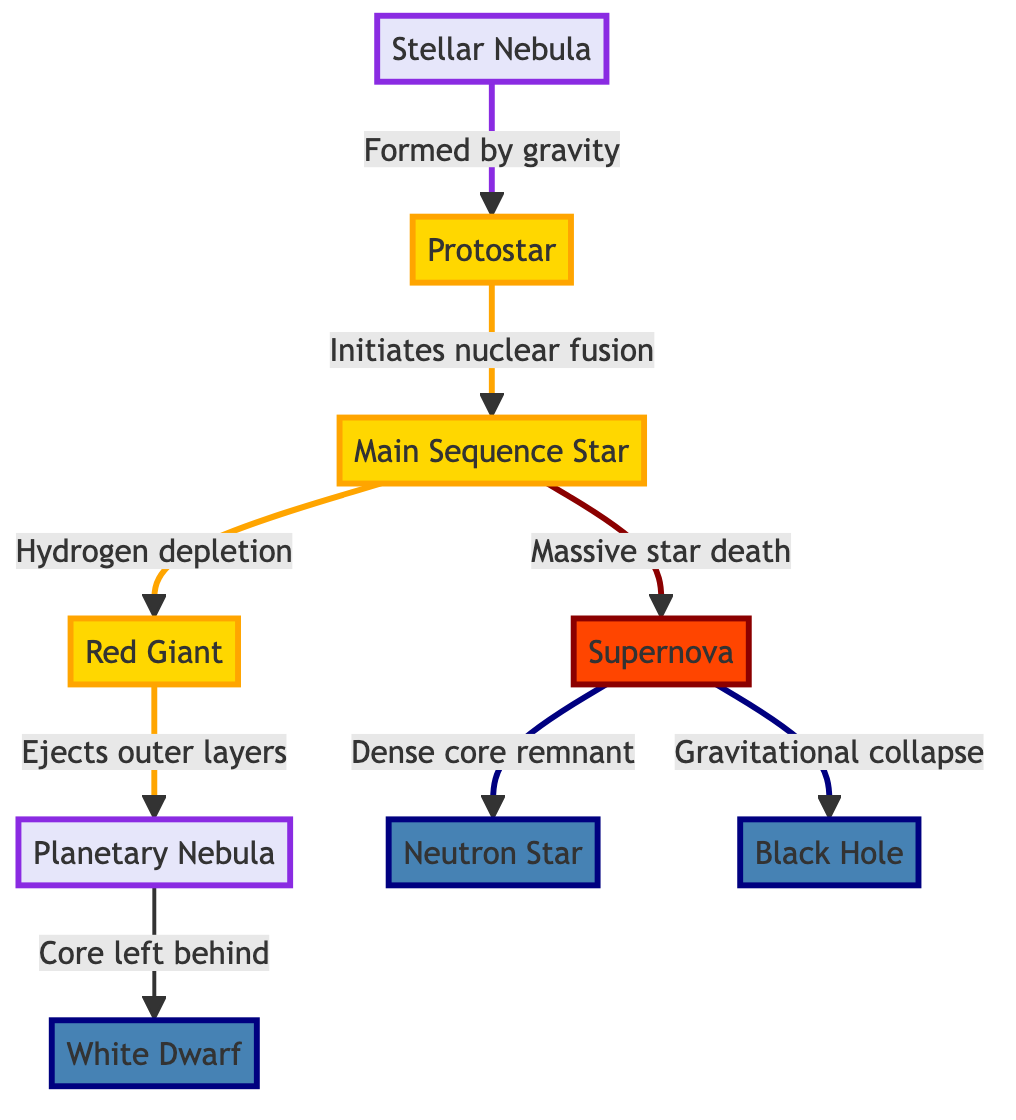What is the first stage of a star's lifecycle? The diagram indicates that the first stage of a star's lifecycle is represented by the node labeled "Stellar Nebula." This is also the starting point of the flow leading to the formation of a star.
Answer: Stellar Nebula How many main stages are shown in the lifecycle of a star? By counting the distinct processes or stages listed in the diagram, we see a total of 9 nodes indicating the stages in a star's lifecycle.
Answer: 9 What follows after the "Red Giant" stage? The diagram clearly shows that after the "Red Giant," the next process is the ejection of outer layers, resulting in the formation of a "Planetary Nebula."
Answer: Planetary Nebula What is formed after a "Supernova"? The diagram illustrates that after a "Supernova," two possible remnants can form: a "Neutron Star" or a "Black Hole," based on different outcomes of the star's death.
Answer: Neutron Star or Black Hole What triggers the formation of a "Protostar"? The transition to the "Protostar" occurs when the "Stellar Nebula" formed by gravity is further compressed, leading to the next phase. This relationship is shown as an arrow labeled "Formed by gravity."
Answer: Formed by gravity What happens during "Hydrogen depletion"? "Hydrogen depletion" occurs at the "Main Sequence Star" stage when the hydrogen fuel is consumed in nuclear fusion, leading to the transformation into a "Red Giant." This is depicted with a directed arrow in the diagram.
Answer: Red Giant Which node is associated with the term "Ejects outer layers"? The term "Ejects outer layers" is directly linked to the node "Red Giant," indicating a specific event that takes place at this stage before progressing to the "Planetary Nebula."
Answer: Red Giant How does a "Black Hole" form? In the diagram, a "Black Hole" forms as a result of "Gravitational collapse" following the process of a supernova for massive stars. This process is highlighted by an arrow showing the flow from "Supernova" to "Black Hole."
Answer: Gravitational collapse What color represents a "White Dwarf" in the diagram? The "White Dwarf" is represented by a blue color (#4682B4), which is specified in the diagram's class definitions for the remnant stages.
Answer: Blue 